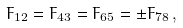Convert formula to latex. <formula><loc_0><loc_0><loc_500><loc_500>F _ { 1 2 } = F _ { 4 3 } = F _ { 6 5 } = \pm F _ { 7 8 } \, ,</formula> 